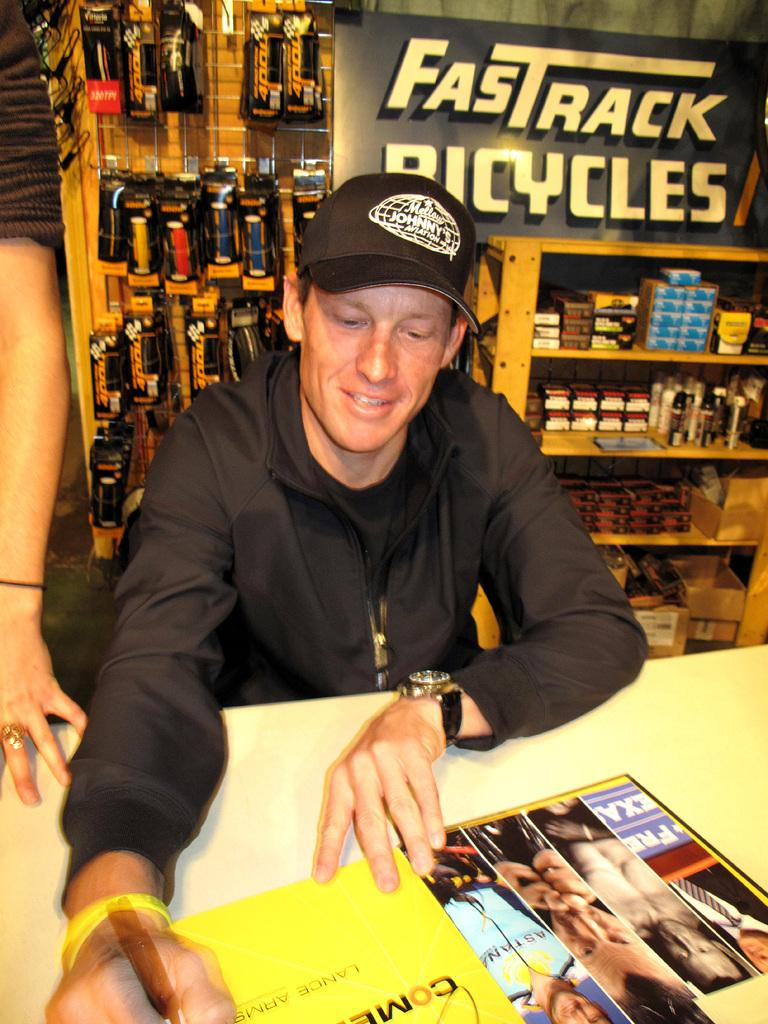<image>
Share a concise interpretation of the image provided. A man signs books in front of a sign that says FasTrack Bicycles. 